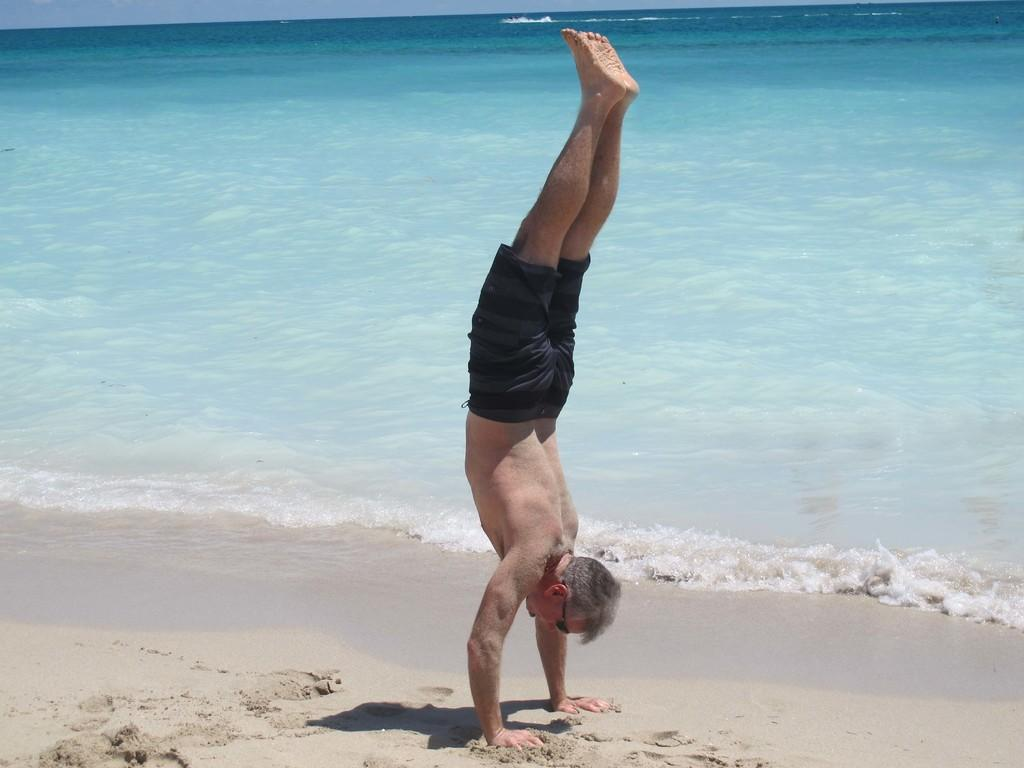What is the location of the man in the image? The man is on the sea shore. What is the man wearing on his face? The man is wearing goggles. How is the man positioned in the image? The man is in an inverted position. What natural element can be seen in the image? Water is visible in the image. What part of the sky can be seen in the image? The sky is visible in the image. What type of tin can be seen in the man's hand in the image? There is no tin present in the image; the man is in an inverted position on the sea shore. 